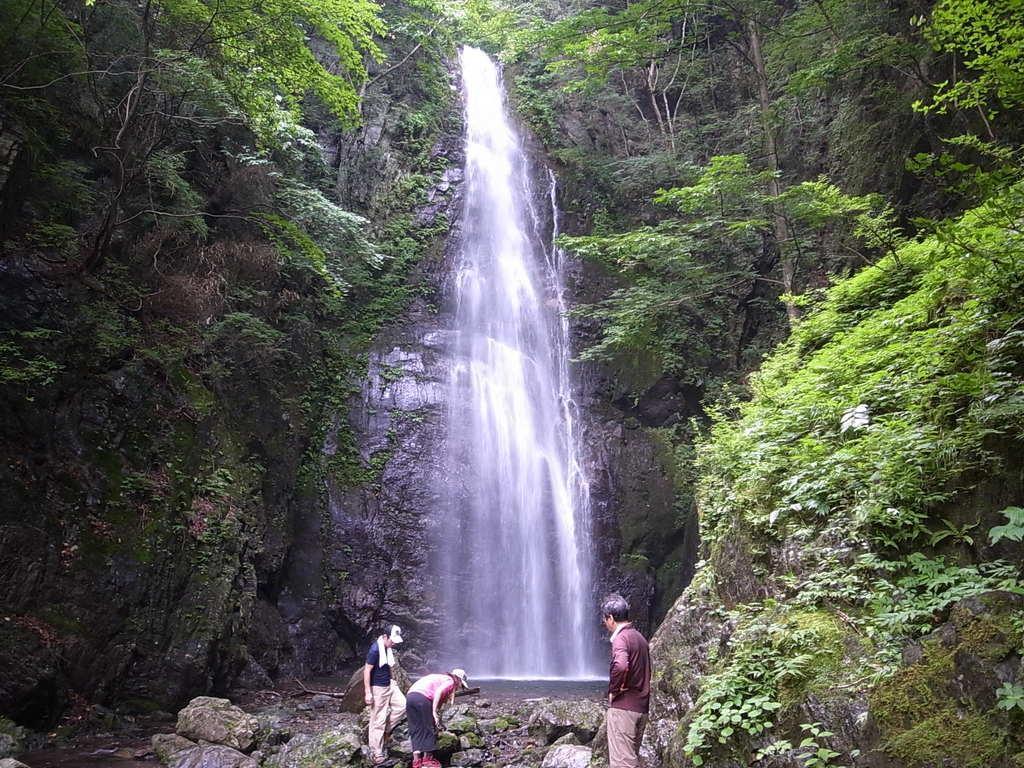In one or two sentences, can you explain what this image depicts? In the foreground of this image, there are three persons standing on the stones. On either side, there is rocks and trees. In the background, there is waterfall. 